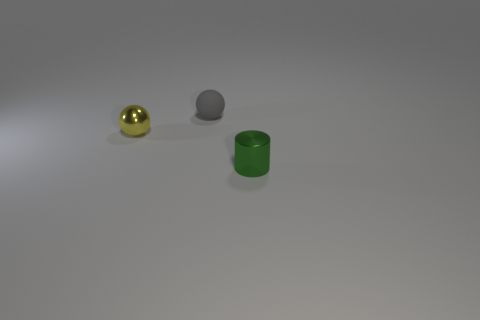Subtract all gray balls. How many balls are left? 1 Subtract all blue balls. How many blue cylinders are left? 0 Subtract all tiny balls. Subtract all large purple things. How many objects are left? 1 Add 2 small green cylinders. How many small green cylinders are left? 3 Add 1 tiny metallic spheres. How many tiny metallic spheres exist? 2 Add 3 small shiny spheres. How many objects exist? 6 Subtract 1 yellow spheres. How many objects are left? 2 Subtract all balls. How many objects are left? 1 Subtract all red spheres. Subtract all gray cylinders. How many spheres are left? 2 